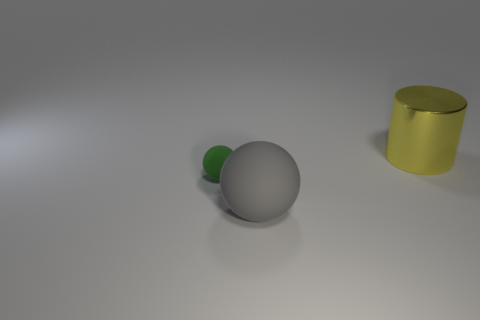Add 2 small blue rubber objects. How many objects exist? 5 Subtract all cylinders. How many objects are left? 2 Subtract 1 cylinders. How many cylinders are left? 0 Add 3 yellow cylinders. How many yellow cylinders exist? 4 Subtract 1 gray balls. How many objects are left? 2 Subtract all yellow spheres. Subtract all green blocks. How many spheres are left? 2 Subtract all gray cylinders. How many cyan balls are left? 0 Subtract all yellow cylinders. Subtract all small gray spheres. How many objects are left? 2 Add 2 matte objects. How many matte objects are left? 4 